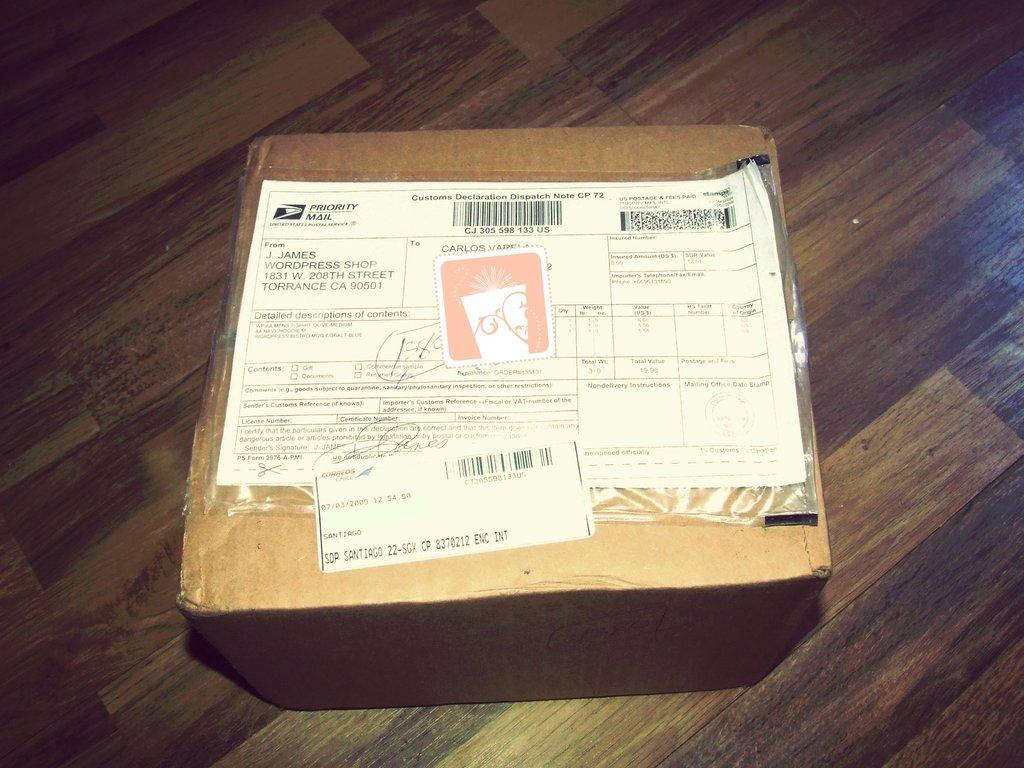<image>
Create a compact narrative representing the image presented. A package that was delivered via Priority Mail sits on the floor. 